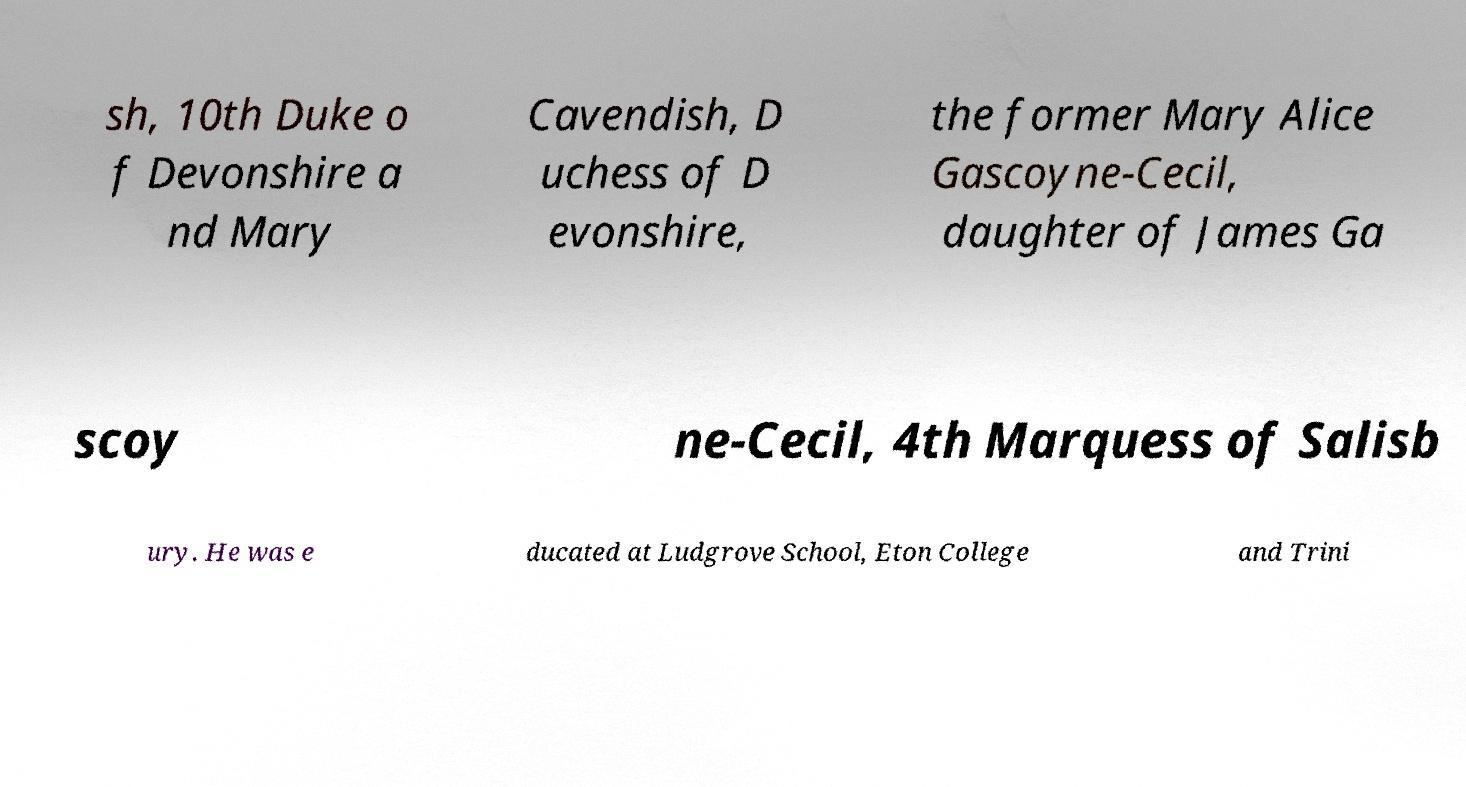For documentation purposes, I need the text within this image transcribed. Could you provide that? sh, 10th Duke o f Devonshire a nd Mary Cavendish, D uchess of D evonshire, the former Mary Alice Gascoyne-Cecil, daughter of James Ga scoy ne-Cecil, 4th Marquess of Salisb ury. He was e ducated at Ludgrove School, Eton College and Trini 